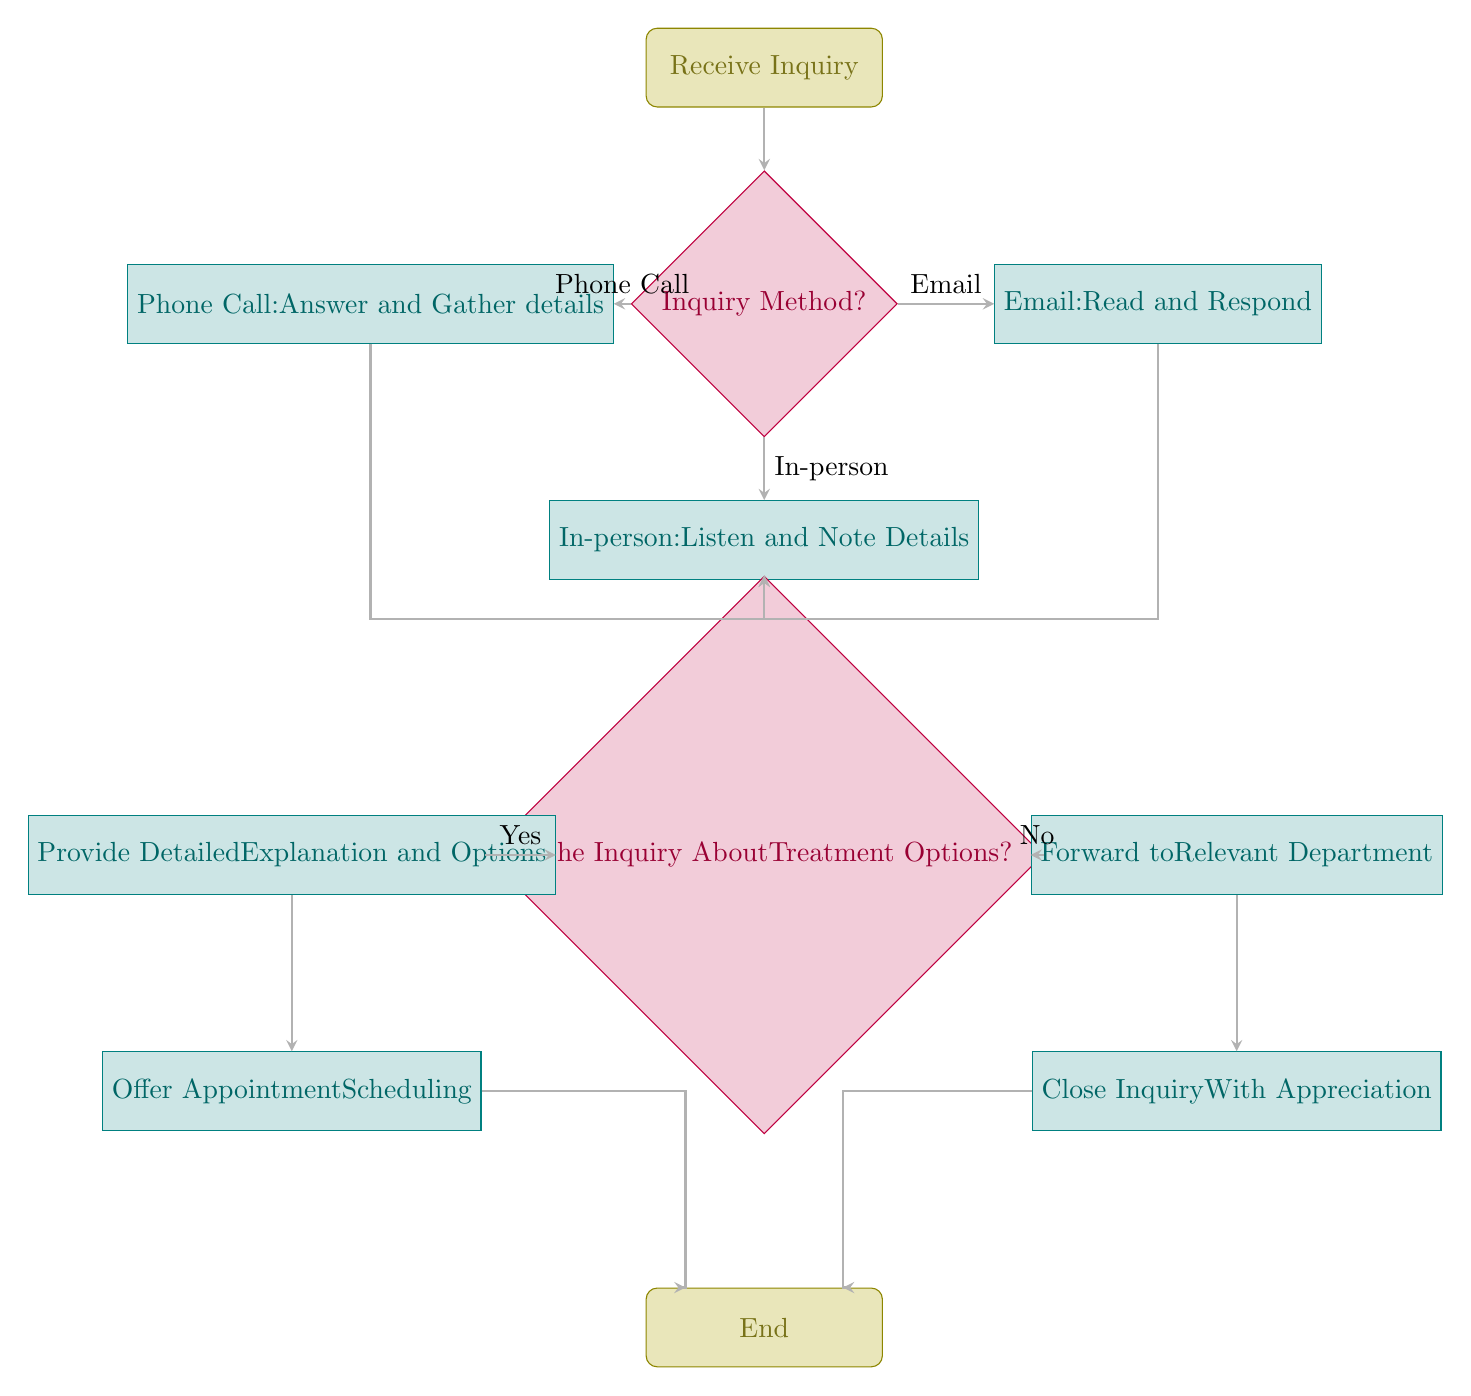What is the starting node of the flow chart? The flow chart begins with the "Receive Inquiry" node, which is the initial step in the process and marked as the starting point.
Answer: Receive Inquiry How many decision nodes are present in the diagram? The diagram contains two decision nodes: "Inquiry Method?" and "Is the Inquiry About Treatment Options?" This shows two points where the flow can change based on conditions.
Answer: 2 What happens after a phone call inquiry is received? After a phone call inquiry is received, the process proceeds to "Answer and Gather details," after which it goes to the decision node "Is the Inquiry About Treatment Options?"
Answer: Answer and Gather details What are the two possible outcomes if the inquiry is not about treatment options? If the inquiry is not about treatment options, the process will move to "Forward to Relevant Department," followed by "Close Inquiry With Appreciation." These paths are specifically taken based on the condition evaluated in the decision node.
Answer: Forward to Relevant Department, Close Inquiry With Appreciation Which action follows after providing detailed explanations and options? After providing detailed explanations and options, the next action is "Offer Appointment Scheduling," which allows the patient to arrange their appointments based on the treatment options discussed.
Answer: Offer Appointment Scheduling What are the methods of inquiry listed in the decision node? The methods of inquiry listed in the decision node are "Phone Call," "Email," and "In-person." These represent the different ways patients can reach out for inquiries.
Answer: Phone Call, Email, In-person What is the final node that concludes the protocol? The final node that concludes the protocol is labeled "End," which signifies the completion of the inquiry process after all necessary actions have been taken.
Answer: End After listening and noting details for an in-person inquiry, what is the next step? After listening and noting details for an in-person inquiry, the flow proceeds to the decision node "Is the Inquiry About Treatment Options?" where it will determine the next action based on the inquiry's content.
Answer: Is the Inquiry About Treatment Options? What is the process immediately after an email inquiry is read? The process immediately after an email inquiry is read is to respond to the email, which is documented as "Email: Read and Respond" before moving on to the next decision node.
Answer: Read and Respond 